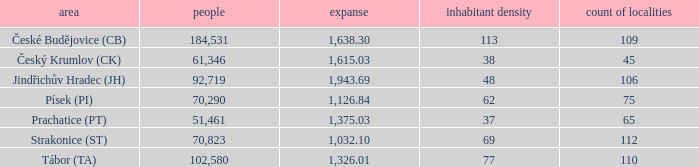How big is the area that has a population density of 113 and a population larger than 184,531? 0.0. 